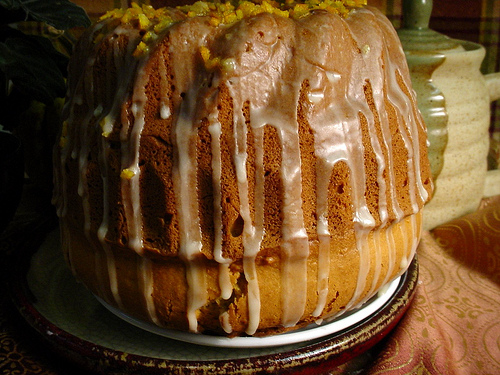<image>
Is the glaze on the cake? Yes. Looking at the image, I can see the glaze is positioned on top of the cake, with the cake providing support. 